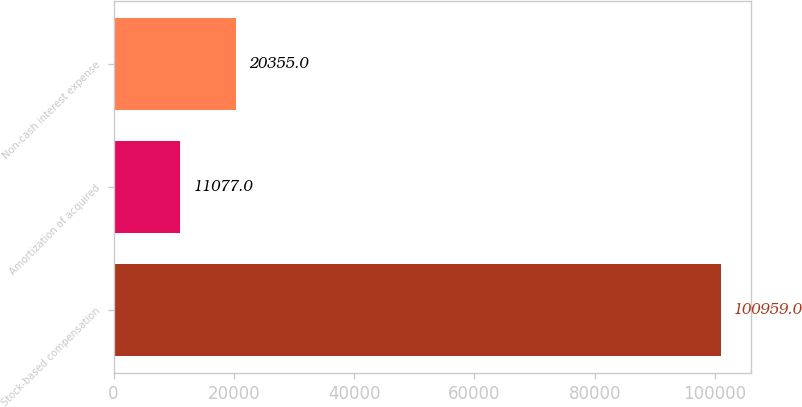Convert chart to OTSL. <chart><loc_0><loc_0><loc_500><loc_500><bar_chart><fcel>Stock-based compensation<fcel>Amortization of acquired<fcel>Non-cash interest expense<nl><fcel>100959<fcel>11077<fcel>20355<nl></chart> 